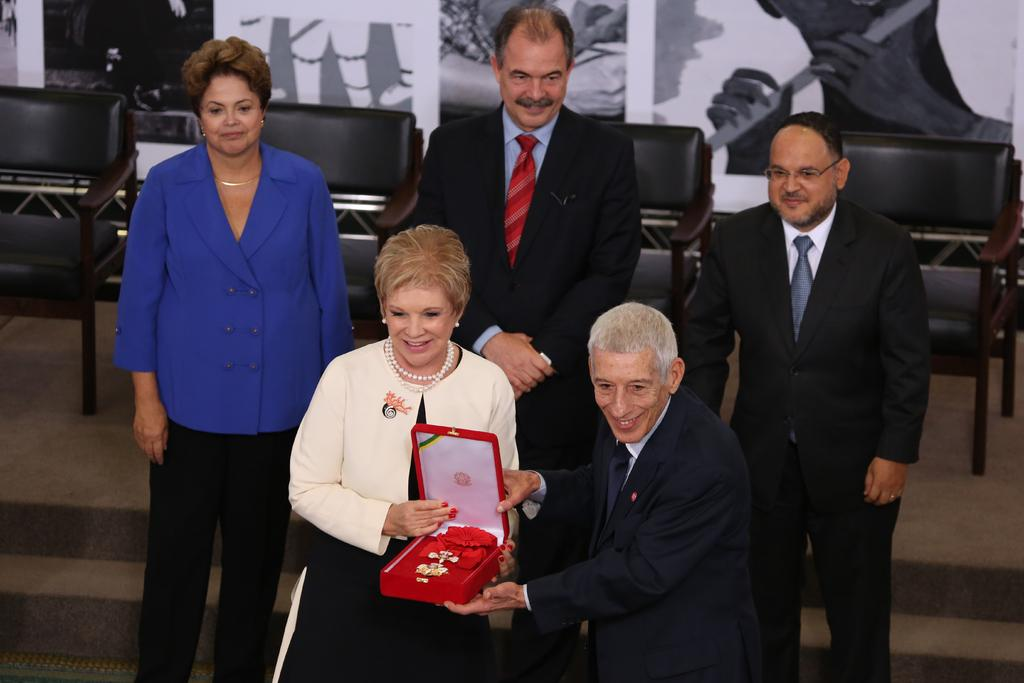What can be seen in the front of the image? There are people and chairs in the front of the image. What are the people doing in the image? Two people are holding a box. What is visible in the background of the image? There are boards in the background of the image. How many points are visible on the boards in the image? There is no mention of points on the boards in the image; they are simply described as boards. Can you tell me how the two people are expressing their love for each other in the image? There is no indication of love or affection between the two people holding the box in the image. 